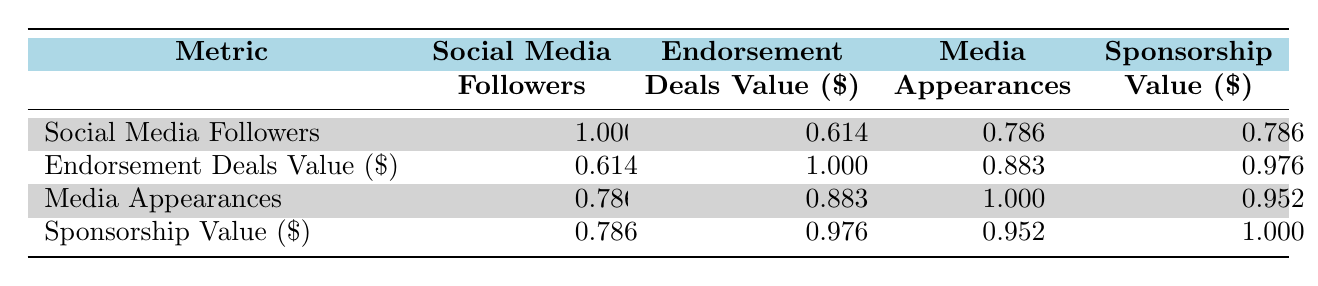What is the correlation coefficient between social media followers and endorsement deals value? The table shows the correlation coefficient between social media followers and endorsement deals value as 0.614.
Answer: 0.614 Which athlete has the highest media appearances? By examining the media appearances values, LeBron James has the highest count at 50.
Answer: LeBron James What is the correlation coefficient between sponsorship value and endorsement deals value? The table indicates the correlation coefficient between sponsorship value and endorsement deals value is 0.976.
Answer: 0.976 Is there a strong correlation between media appearances and social media followers? The correlation coefficient between media appearances and social media followers is 0.786, which indicates a strong correlation.
Answer: Yes What is the average correlation coefficient between the four metrics listed? To find the average, add the coefficients (1.000 + 0.614 + 0.786 + 0.976 + 0.883 + 0.952) and divide by the number of values (6). This sums to 5.211, so the average is 5.211/6 ≈ 0.868.
Answer: Approximately 0.868 Which metric has the strongest correlation with sponsorship value? The table shows that sponsorship value has the strongest correlation with endorsement deals value, which is 0.976.
Answer: Endorsement deals value Are there any metrics that correlate perfectly with each other? The correlation between social media followers and itself is 1.000, which indicates a perfect correlation; however, all other metrics have less than perfect correlation.
Answer: Yes, social media followers correlate with itself Which athlete has the least social media followers? By reviewing the social media followers, Tom Brady and Serena Williams both have 10,000,000, making them the athletes with the least followers.
Answer: Tom Brady and Serena Williams 